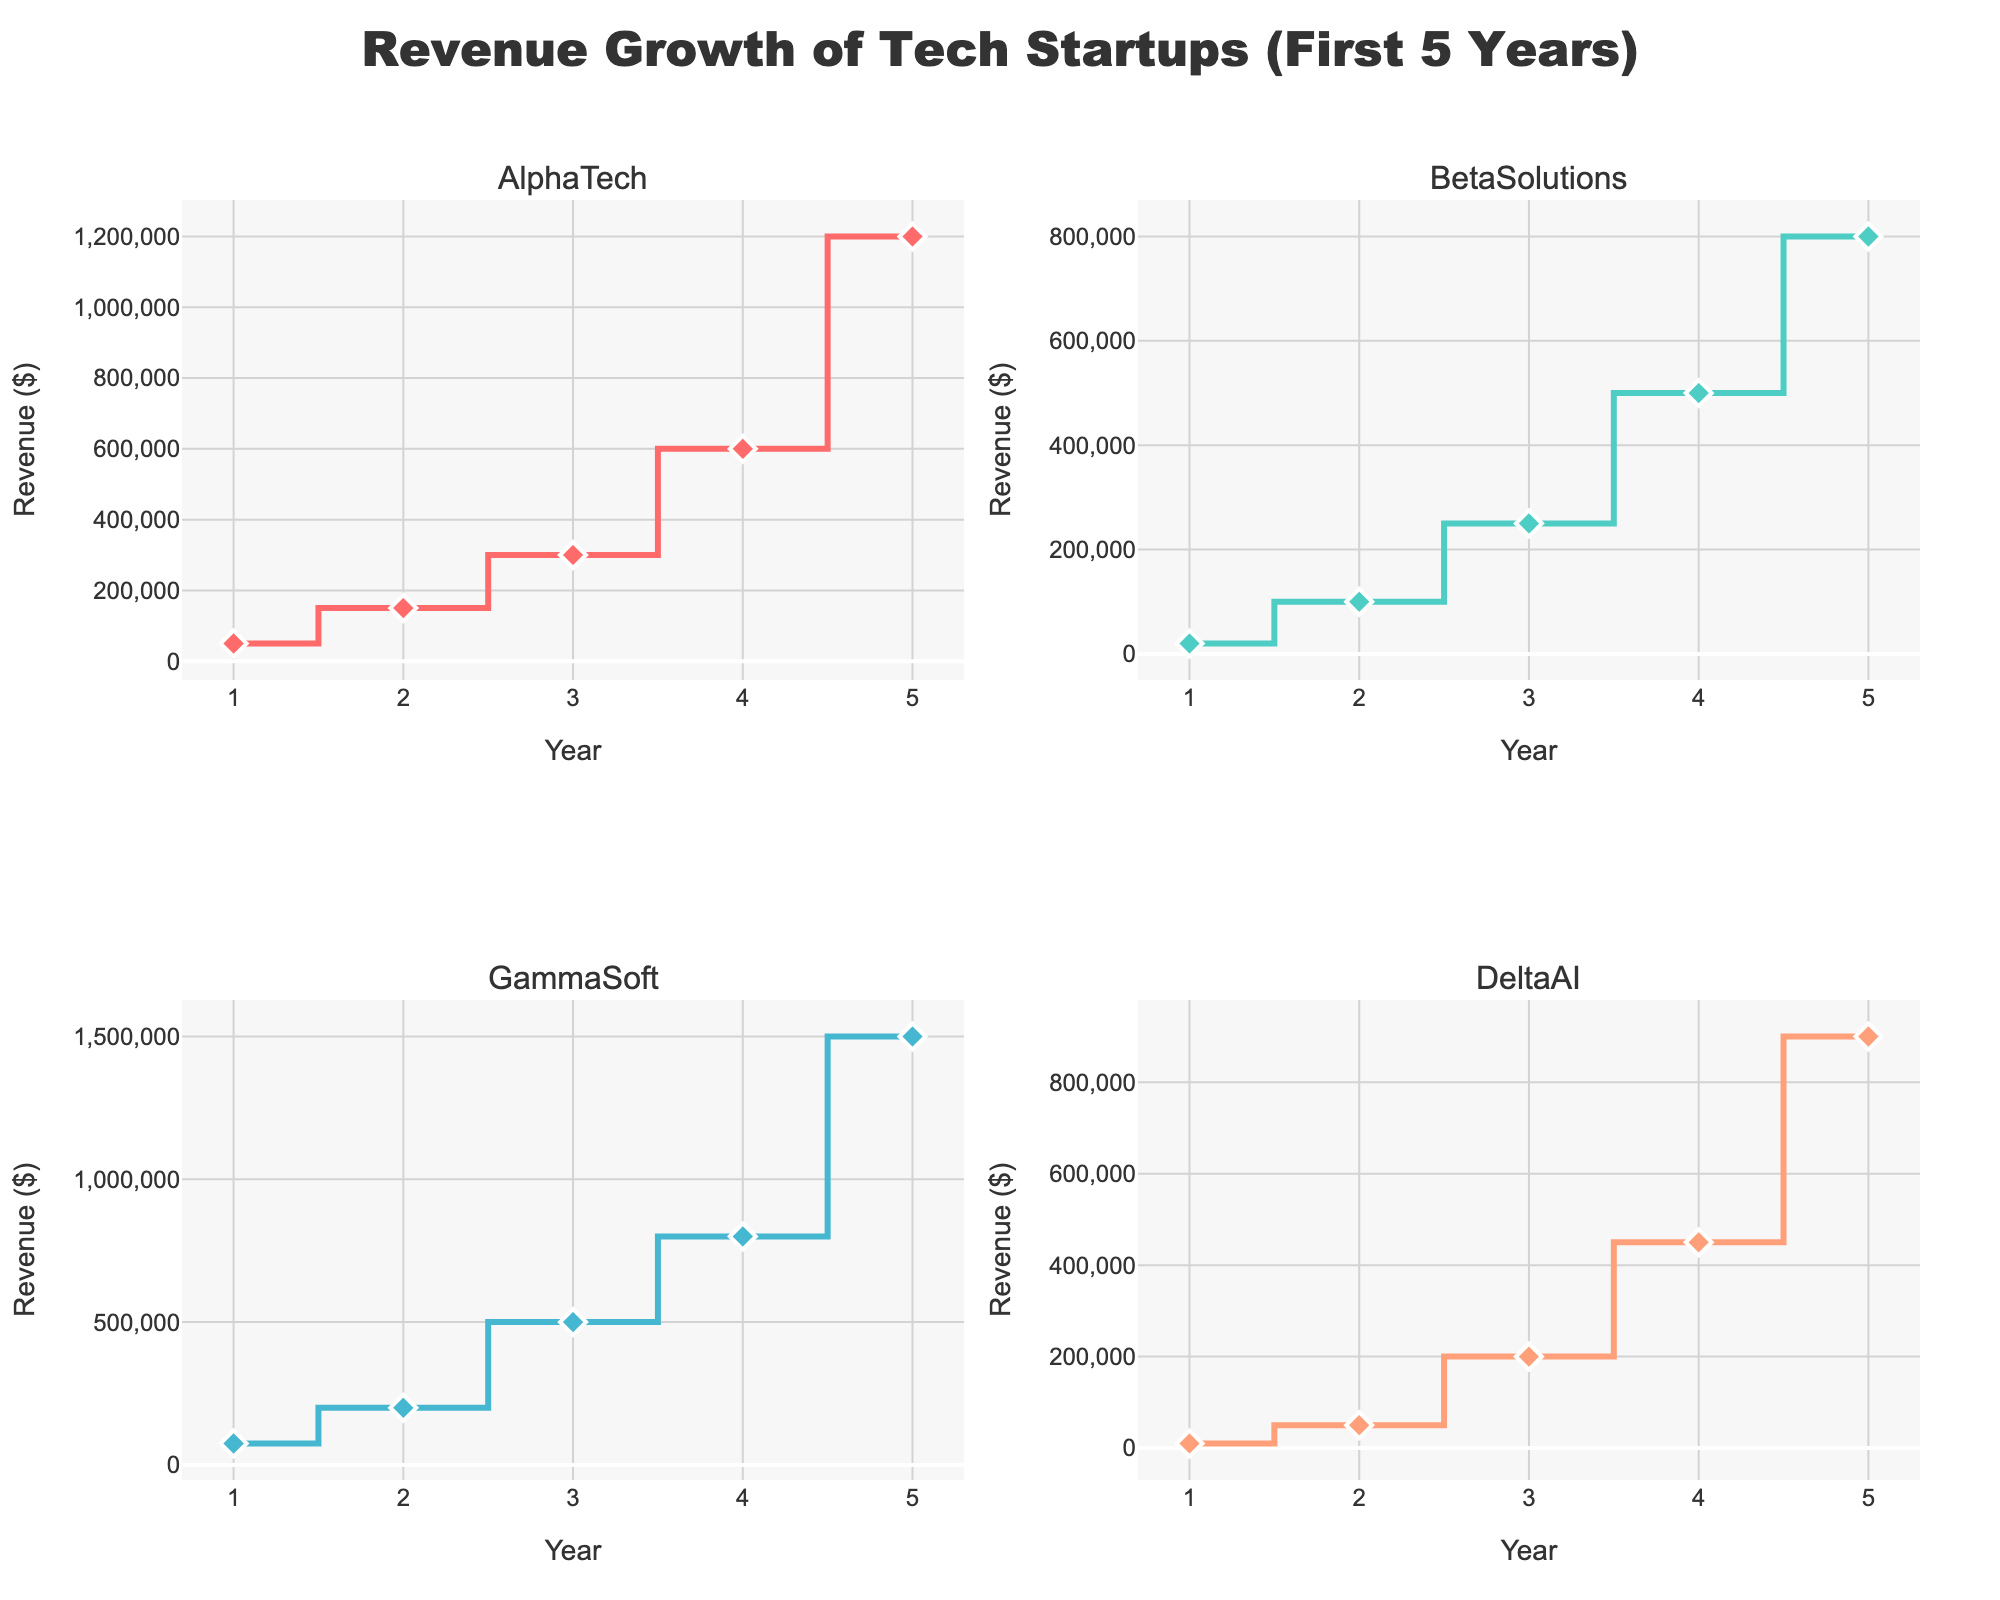What's the title of the figure? The title is located at the top center of the figure, indicating the overall theme of the data being presented.
Answer: Revenue Growth of Tech Startups (First 5 Years) Which company had the highest revenue in its first year? Analyze the revenue values for the first year in each subplot to determine the highest value. GammaSoft had a revenue of $75,000, which is the highest among all companies in their first year.
Answer: GammaSoft What is the total revenue of AlphaTech over the first five years? Sum the revenue for each year for AlphaTech: 50,000 + 150,000 + 300,000 + 600,000 + 1,200,000 = 2,300,000
Answer: 2,300,000 By how much did BetaSolutions' revenue increase from year 1 to year 5? Subtract BetaSolutions’ revenue in year 1 from its revenue in year 5: 800,000 - 20,000 = 780,000
Answer: 780,000 Which company shows the steepest revenue growth in year 4 to year 5? Compare the revenue increase from year 4 to year 5 for all companies: 
- AlphaTech: 1,200,000 - 600,000 = 600,000
- BetaSolutions: 800,000 - 500,000 = 300,000
- GammaSoft: 1,500,000 - 800,000 = 700,000
- DeltaAI: 900,000 - 450,000 = 450,000
GammaSoft shows the steepest growth with an increase of $700,000.
Answer: GammaSoft What's the average revenue of DeltaAI over the first five years? Sum the revenue for each year for DeltaAI, then divide by 5: (10,000 + 50,000 + 200,000 + 450,000 + 900,000) / 5 = 322,000
Answer: 322,000 Which company had the lowest revenue in the second year? Compare the revenue values for the second year across all companies: 
- AlphaTech: $150,000
- BetaSolutions: $100,000
- GammaSoft: $200,000
- DeltaAI: $50,000
DeltaAI has the lowest revenue in the second year.
Answer: DeltaAI What's the revenue difference between GammaSoft and AlphaTech in year 3? Subtract AlphaTech’s revenue from GammaSoft's in year 3:
500,000 - 300,000 = 200,000
Answer: 200,000 How many data points are depicted for each company? By looking at each subplot, it is evident that each company has data points for years 1 through 5, resulting in 5 data points per company.
Answer: 5 What color represents BetaSolutions in the figure? Observe the colors assigned to each company's plot. BetaSolutions is represented by the color teal (second color in the list).
Answer: Teal 